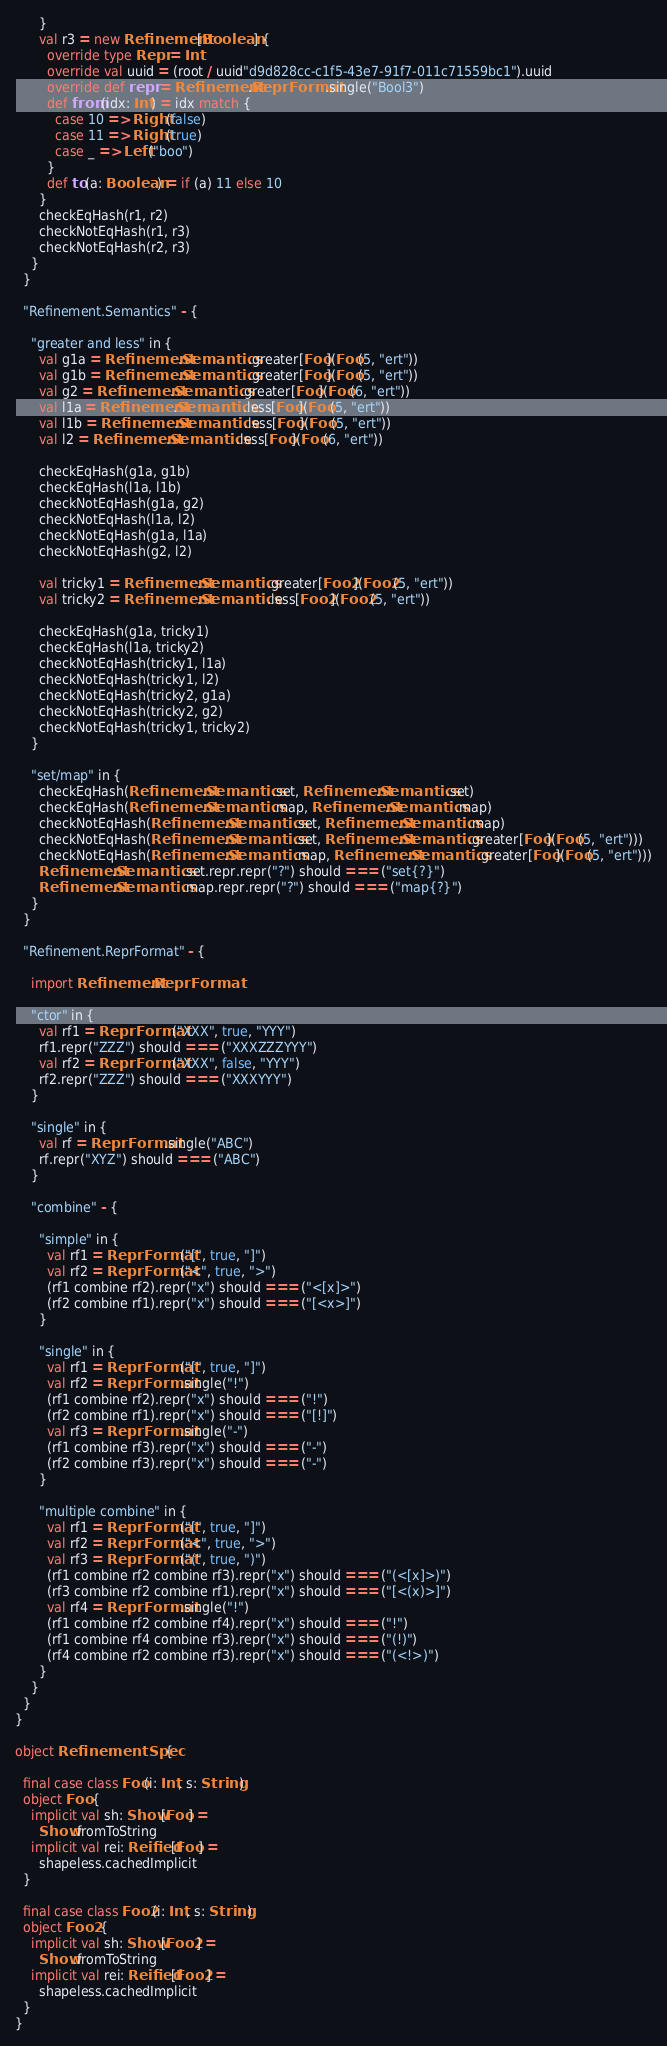<code> <loc_0><loc_0><loc_500><loc_500><_Scala_>      }
      val r3 = new Refinement[Boolean] {
        override type Repr = Int
        override val uuid = (root / uuid"d9d828cc-c1f5-43e7-91f7-011c71559bc1").uuid
        override def repr = Refinement.ReprFormat.single("Bool3")
        def from(idx: Int) = idx match {
          case 10 => Right(false)
          case 11 => Right(true)
          case _ => Left("boo")
        }
        def to(a: Boolean) = if (a) 11 else 10
      }
      checkEqHash(r1, r2)
      checkNotEqHash(r1, r3)
      checkNotEqHash(r2, r3)
    }
  }

  "Refinement.Semantics" - {

    "greater and less" in {
      val g1a = Refinement.Semantics.greater[Foo](Foo(5, "ert"))
      val g1b = Refinement.Semantics.greater[Foo](Foo(5, "ert"))
      val g2 = Refinement.Semantics.greater[Foo](Foo(6, "ert"))
      val l1a = Refinement.Semantics.less[Foo](Foo(5, "ert"))
      val l1b = Refinement.Semantics.less[Foo](Foo(5, "ert"))
      val l2 = Refinement.Semantics.less[Foo](Foo(6, "ert"))

      checkEqHash(g1a, g1b)
      checkEqHash(l1a, l1b)
      checkNotEqHash(g1a, g2)
      checkNotEqHash(l1a, l2)
      checkNotEqHash(g1a, l1a)
      checkNotEqHash(g2, l2)

      val tricky1 = Refinement.Semantics.greater[Foo2](Foo2(5, "ert"))
      val tricky2 = Refinement.Semantics.less[Foo2](Foo2(5, "ert"))

      checkEqHash(g1a, tricky1)
      checkEqHash(l1a, tricky2)
      checkNotEqHash(tricky1, l1a)
      checkNotEqHash(tricky1, l2)
      checkNotEqHash(tricky2, g1a)
      checkNotEqHash(tricky2, g2)
      checkNotEqHash(tricky1, tricky2)
    }

    "set/map" in {
      checkEqHash(Refinement.Semantics.set, Refinement.Semantics.set)
      checkEqHash(Refinement.Semantics.map, Refinement.Semantics.map)
      checkNotEqHash(Refinement.Semantics.set, Refinement.Semantics.map)
      checkNotEqHash(Refinement.Semantics.set, Refinement.Semantics.greater[Foo](Foo(5, "ert")))
      checkNotEqHash(Refinement.Semantics.map, Refinement.Semantics.greater[Foo](Foo(5, "ert")))
      Refinement.Semantics.set.repr.repr("?") should === ("set{?}")
      Refinement.Semantics.map.repr.repr("?") should === ("map{?}")
    }
  }

  "Refinement.ReprFormat" - {

    import Refinement.ReprFormat

    "ctor" in {
      val rf1 = ReprFormat("XXX", true, "YYY")
      rf1.repr("ZZZ") should === ("XXXZZZYYY")
      val rf2 = ReprFormat("XXX", false, "YYY")
      rf2.repr("ZZZ") should === ("XXXYYY")
    }

    "single" in {
      val rf = ReprFormat.single("ABC")
      rf.repr("XYZ") should === ("ABC")
    }

    "combine" - {

      "simple" in {
        val rf1 = ReprFormat("[", true, "]")
        val rf2 = ReprFormat("<", true, ">")
        (rf1 combine rf2).repr("x") should === ("<[x]>")
        (rf2 combine rf1).repr("x") should === ("[<x>]")
      }

      "single" in {
        val rf1 = ReprFormat("[", true, "]")
        val rf2 = ReprFormat.single("!")
        (rf1 combine rf2).repr("x") should === ("!")
        (rf2 combine rf1).repr("x") should === ("[!]")
        val rf3 = ReprFormat.single("-")
        (rf1 combine rf3).repr("x") should === ("-")
        (rf2 combine rf3).repr("x") should === ("-")
      }

      "multiple combine" in {
        val rf1 = ReprFormat("[", true, "]")
        val rf2 = ReprFormat("<", true, ">")
        val rf3 = ReprFormat("(", true, ")")
        (rf1 combine rf2 combine rf3).repr("x") should === ("(<[x]>)")
        (rf3 combine rf2 combine rf1).repr("x") should === ("[<(x)>]")
        val rf4 = ReprFormat.single("!")
        (rf1 combine rf2 combine rf4).repr("x") should === ("!")
        (rf1 combine rf4 combine rf3).repr("x") should === ("(!)")
        (rf4 combine rf2 combine rf3).repr("x") should === ("(<!>)")
      }
    }
  }
}

object RefinementSpec {

  final case class Foo(i: Int, s: String)
  object Foo {
    implicit val sh: Show[Foo] =
      Show.fromToString
    implicit val rei: Reified[Foo] =
      shapeless.cachedImplicit
  }

  final case class Foo2(i: Int, s: String)
  object Foo2 {
    implicit val sh: Show[Foo2] =
      Show.fromToString
    implicit val rei: Reified[Foo2] =
      shapeless.cachedImplicit
  }
}
</code> 